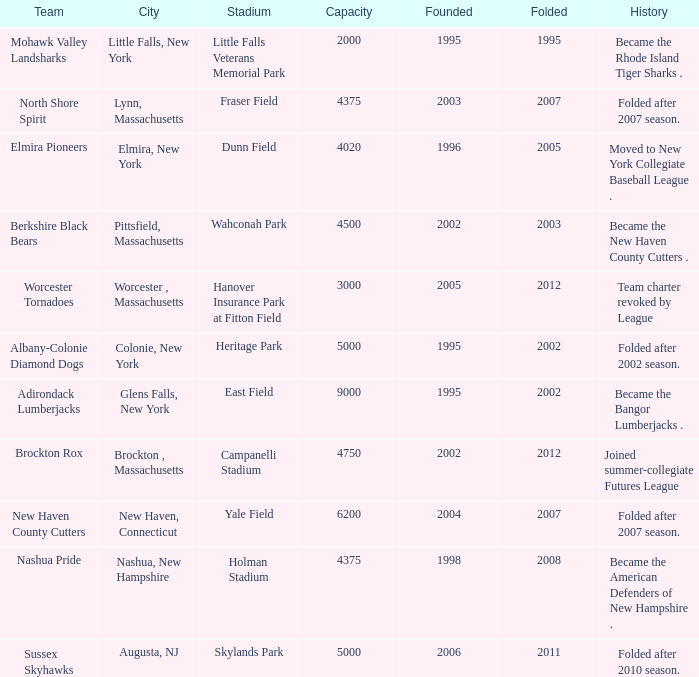What is the maximum folded value of the team whose stadium is Fraser Field? 2007.0. 